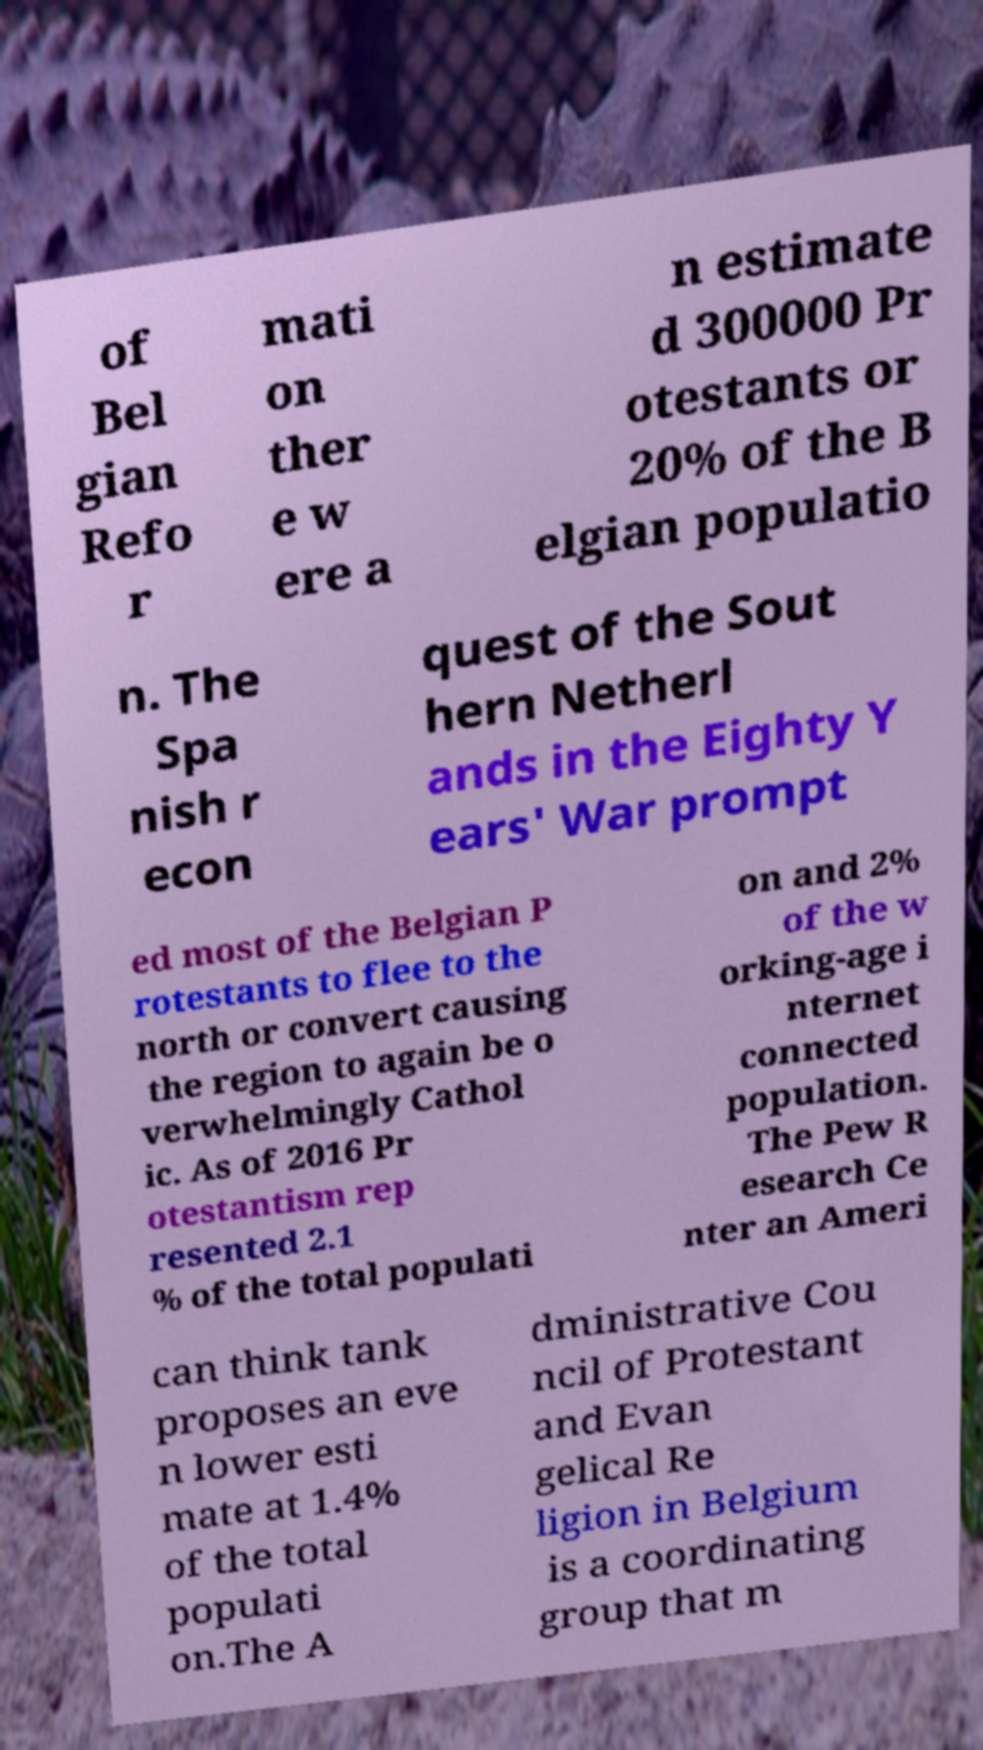Please identify and transcribe the text found in this image. of Bel gian Refo r mati on ther e w ere a n estimate d 300000 Pr otestants or 20% of the B elgian populatio n. The Spa nish r econ quest of the Sout hern Netherl ands in the Eighty Y ears' War prompt ed most of the Belgian P rotestants to flee to the north or convert causing the region to again be o verwhelmingly Cathol ic. As of 2016 Pr otestantism rep resented 2.1 % of the total populati on and 2% of the w orking-age i nternet connected population. The Pew R esearch Ce nter an Ameri can think tank proposes an eve n lower esti mate at 1.4% of the total populati on.The A dministrative Cou ncil of Protestant and Evan gelical Re ligion in Belgium is a coordinating group that m 